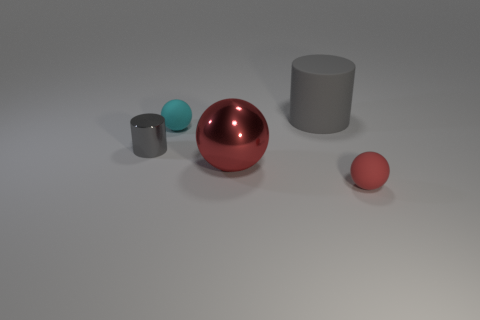Is there a large object that is on the left side of the big thing that is to the left of the big gray object that is right of the red metallic sphere?
Make the answer very short. No. The cyan matte thing is what size?
Give a very brief answer. Small. How many things are either large red shiny spheres or gray metal things?
Keep it short and to the point. 2. What color is the other thing that is the same material as the small gray thing?
Keep it short and to the point. Red. There is a small rubber object in front of the cyan sphere; is it the same shape as the large metallic object?
Your answer should be compact. Yes. What number of things are either spheres that are behind the big ball or big gray matte cylinders that are on the right side of the small cylinder?
Offer a very short reply. 2. There is a large rubber thing that is the same shape as the tiny gray object; what is its color?
Offer a very short reply. Gray. Is there any other thing that has the same shape as the large rubber object?
Your answer should be compact. Yes. Does the cyan matte object have the same shape as the gray object that is to the right of the tiny cylinder?
Provide a succinct answer. No. What material is the big gray cylinder?
Give a very brief answer. Rubber. 